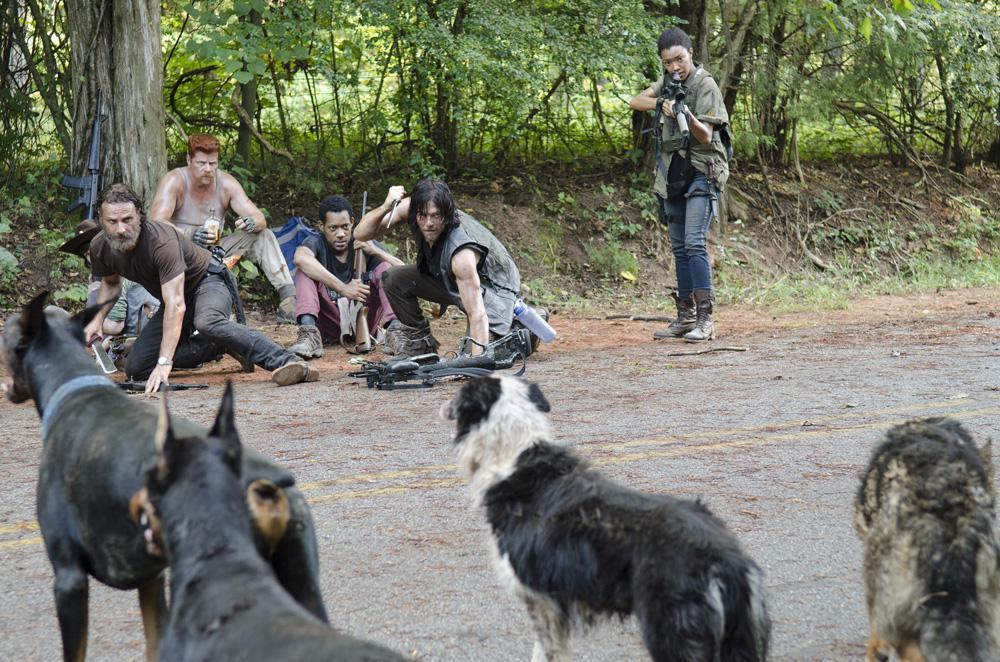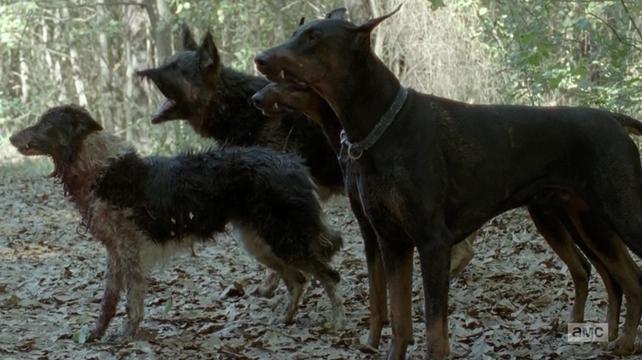The first image is the image on the left, the second image is the image on the right. Given the left and right images, does the statement "One image shows a camera-gazing doberman with a blue tag dangling from its collar and stubby-looking ears." hold true? Answer yes or no. No. The first image is the image on the left, the second image is the image on the right. Given the left and right images, does the statement "There are two dogs." hold true? Answer yes or no. No. 